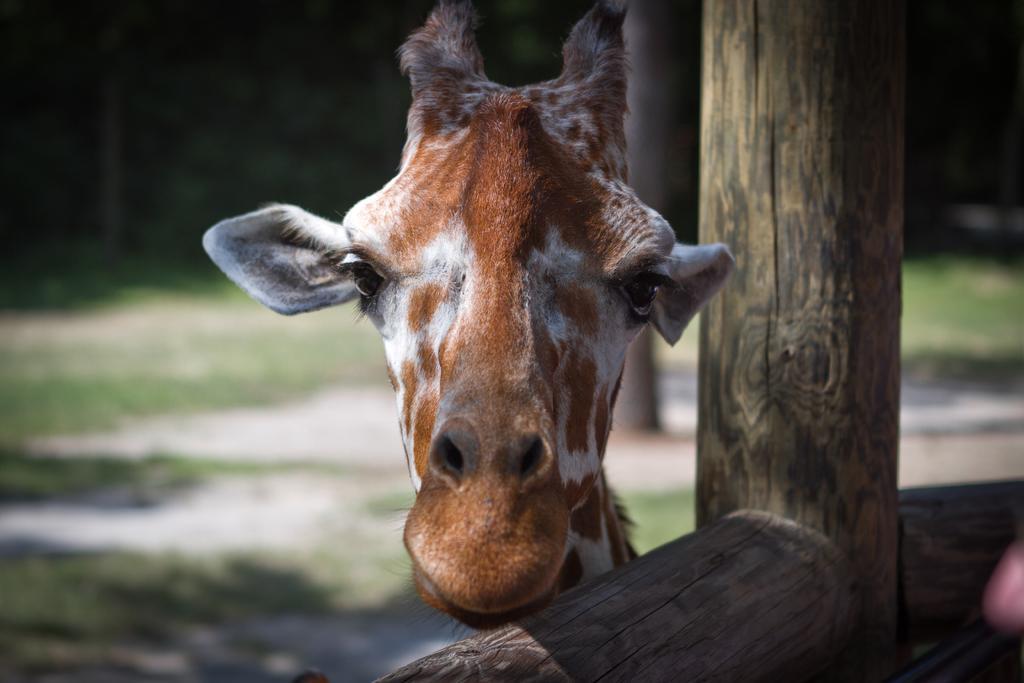In one or two sentences, can you explain what this image depicts? In this image we can see a giraffe's face from a wooden fence. In the background there are trees and ground. 